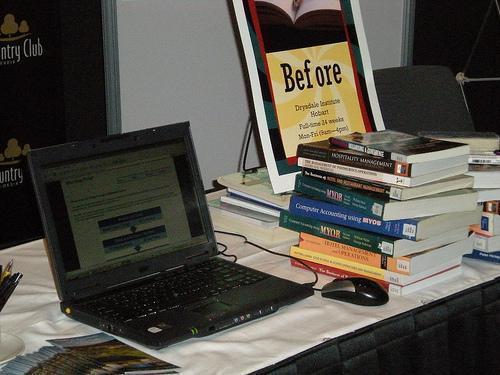How many books are on the first pile?
Give a very brief answer. 10. How many computer mice are on the table?
Give a very brief answer. 1. How many books are in the stack closest to the laptop?
Give a very brief answer. 10. 